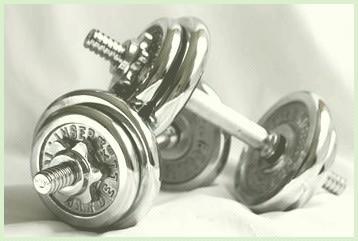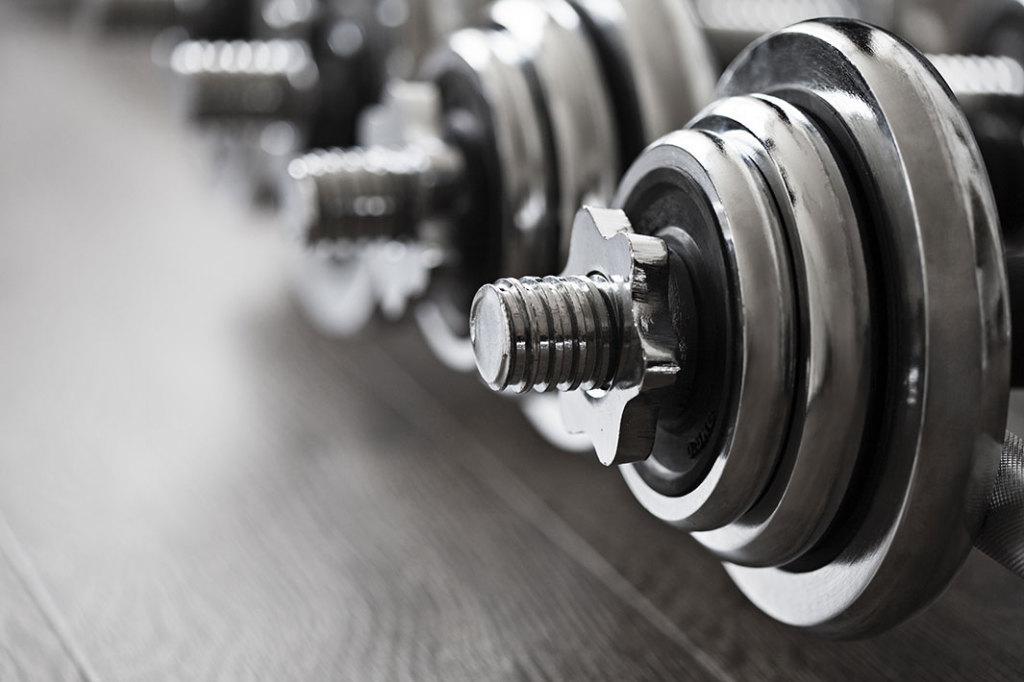The first image is the image on the left, the second image is the image on the right. Considering the images on both sides, is "One image shows a pair of small, matched dumbbells, with the end of one angled onto the bar of the other." valid? Answer yes or no. Yes. 